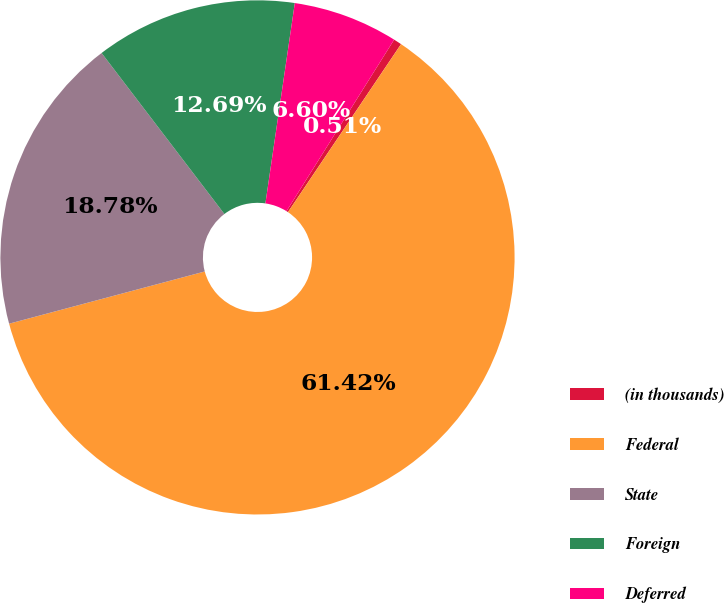Convert chart. <chart><loc_0><loc_0><loc_500><loc_500><pie_chart><fcel>(in thousands)<fcel>Federal<fcel>State<fcel>Foreign<fcel>Deferred<nl><fcel>0.51%<fcel>61.42%<fcel>18.78%<fcel>12.69%<fcel>6.6%<nl></chart> 